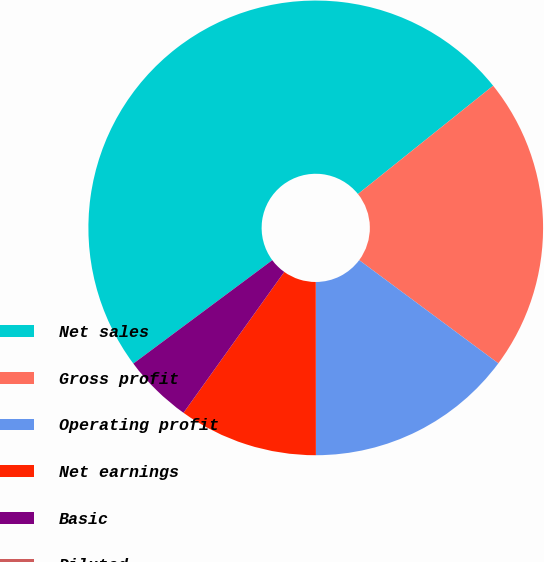Convert chart. <chart><loc_0><loc_0><loc_500><loc_500><pie_chart><fcel>Net sales<fcel>Gross profit<fcel>Operating profit<fcel>Net earnings<fcel>Basic<fcel>Diluted<nl><fcel>49.43%<fcel>20.91%<fcel>14.83%<fcel>9.89%<fcel>4.94%<fcel>0.0%<nl></chart> 